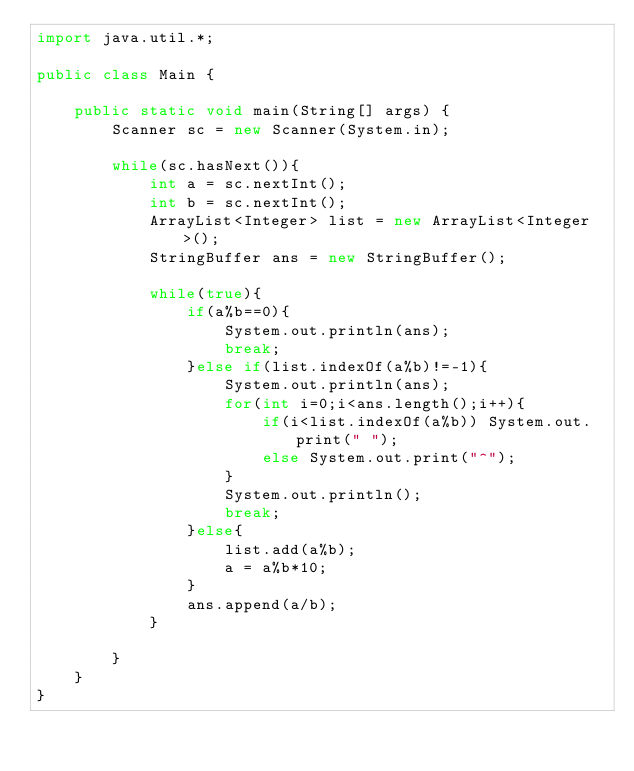<code> <loc_0><loc_0><loc_500><loc_500><_Java_>import java.util.*;

public class Main {
	
	public static void main(String[] args) {
		Scanner sc = new Scanner(System.in);
		
		while(sc.hasNext()){
			int a = sc.nextInt();
			int b = sc.nextInt();
			ArrayList<Integer> list = new ArrayList<Integer>();
			StringBuffer ans = new StringBuffer();
			
			while(true){
				if(a%b==0){
					System.out.println(ans);
					break;
				}else if(list.indexOf(a%b)!=-1){
					System.out.println(ans);
					for(int i=0;i<ans.length();i++){
						if(i<list.indexOf(a%b)) System.out.print(" ");
						else System.out.print("^");
					}
					System.out.println();
					break;
				}else{
					list.add(a%b);
					a = a%b*10;
				}
				ans.append(a/b);
			}
		
		}
	}	
}</code> 